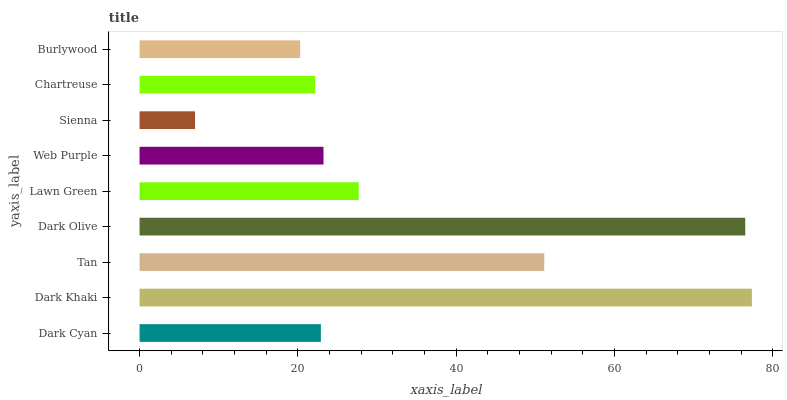Is Sienna the minimum?
Answer yes or no. Yes. Is Dark Khaki the maximum?
Answer yes or no. Yes. Is Tan the minimum?
Answer yes or no. No. Is Tan the maximum?
Answer yes or no. No. Is Dark Khaki greater than Tan?
Answer yes or no. Yes. Is Tan less than Dark Khaki?
Answer yes or no. Yes. Is Tan greater than Dark Khaki?
Answer yes or no. No. Is Dark Khaki less than Tan?
Answer yes or no. No. Is Web Purple the high median?
Answer yes or no. Yes. Is Web Purple the low median?
Answer yes or no. Yes. Is Burlywood the high median?
Answer yes or no. No. Is Chartreuse the low median?
Answer yes or no. No. 